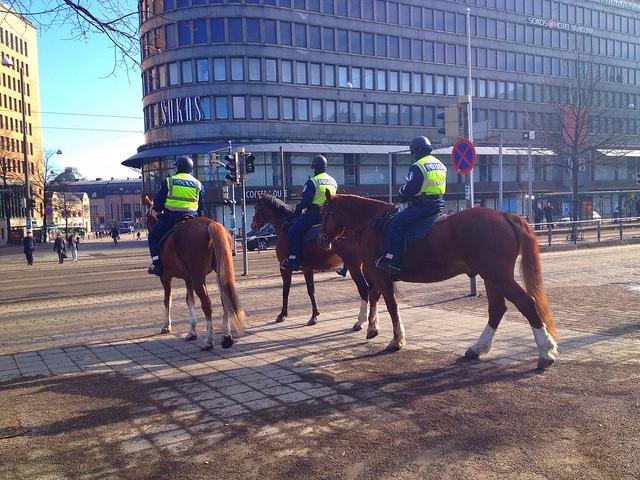What sign is in the photo?
Answer briefly. X. What covers the buildings walls?
Give a very brief answer. Windows. How many people are on horseback?
Be succinct. 3. 